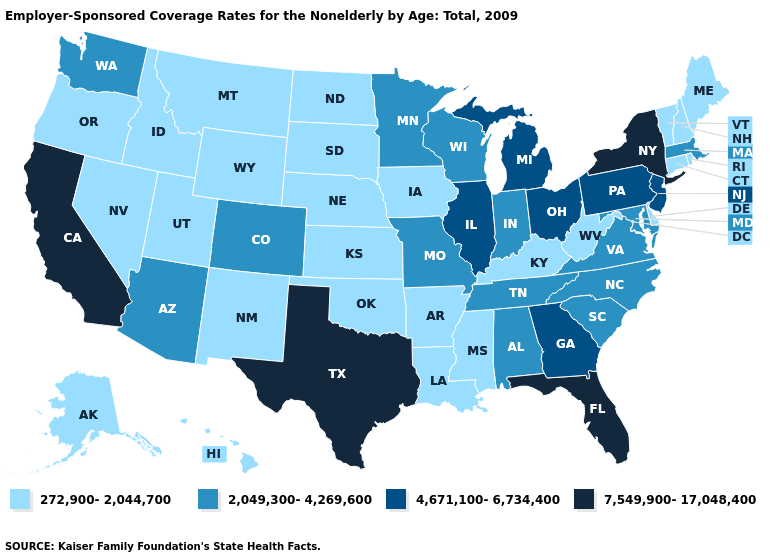What is the lowest value in states that border New Jersey?
Concise answer only. 272,900-2,044,700. What is the value of Hawaii?
Be succinct. 272,900-2,044,700. What is the value of Wisconsin?
Keep it brief. 2,049,300-4,269,600. What is the value of Iowa?
Quick response, please. 272,900-2,044,700. Among the states that border Alabama , which have the lowest value?
Keep it brief. Mississippi. Name the states that have a value in the range 7,549,900-17,048,400?
Keep it brief. California, Florida, New York, Texas. Does Tennessee have the lowest value in the South?
Quick response, please. No. What is the value of Tennessee?
Concise answer only. 2,049,300-4,269,600. What is the lowest value in the USA?
Answer briefly. 272,900-2,044,700. What is the value of Arkansas?
Give a very brief answer. 272,900-2,044,700. What is the highest value in the USA?
Short answer required. 7,549,900-17,048,400. What is the lowest value in the USA?
Give a very brief answer. 272,900-2,044,700. Is the legend a continuous bar?
Write a very short answer. No. What is the value of Rhode Island?
Be succinct. 272,900-2,044,700. Does the first symbol in the legend represent the smallest category?
Be succinct. Yes. 